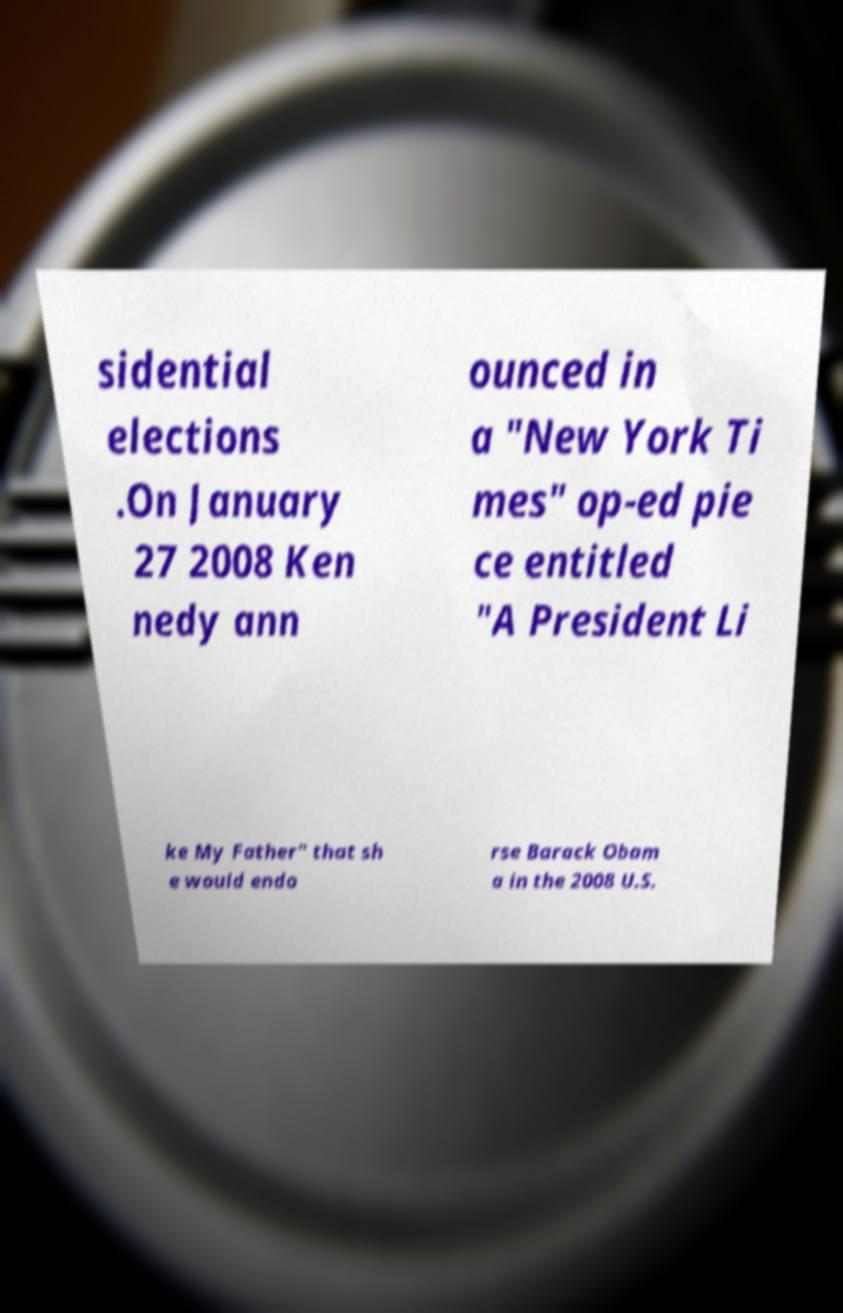I need the written content from this picture converted into text. Can you do that? sidential elections .On January 27 2008 Ken nedy ann ounced in a "New York Ti mes" op-ed pie ce entitled "A President Li ke My Father" that sh e would endo rse Barack Obam a in the 2008 U.S. 